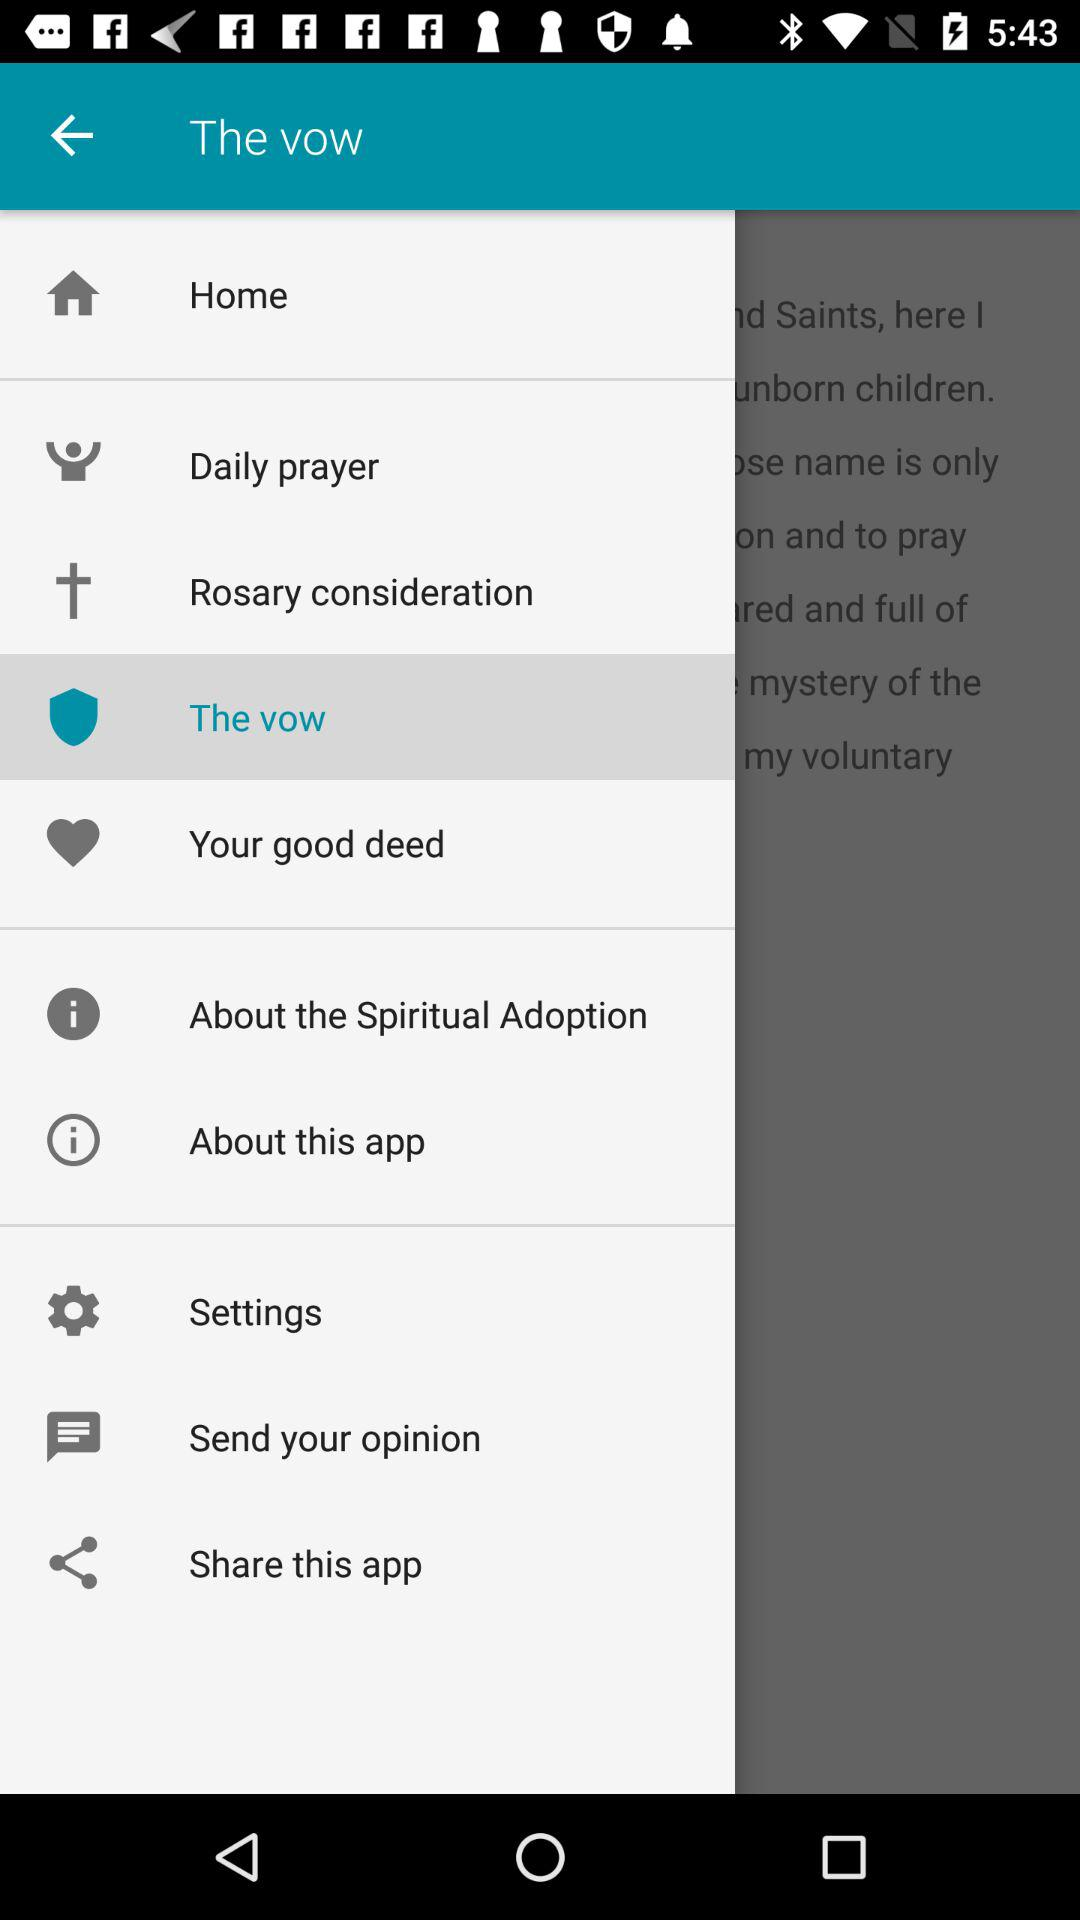What is the selected item? The selected item is "The vow". 